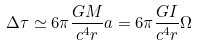Convert formula to latex. <formula><loc_0><loc_0><loc_500><loc_500>\Delta \tau \simeq 6 \pi \frac { G M } { c ^ { 4 } r } a = 6 \pi \frac { G I } { c ^ { 4 } r } \Omega</formula> 